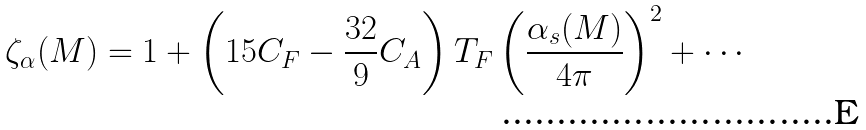Convert formula to latex. <formula><loc_0><loc_0><loc_500><loc_500>\zeta _ { \alpha } ( M ) = 1 + \left ( 1 5 C _ { F } - \frac { 3 2 } { 9 } C _ { A } \right ) T _ { F } \left ( \frac { \alpha _ { s } ( M ) } { 4 \pi } \right ) ^ { 2 } + \cdots</formula> 